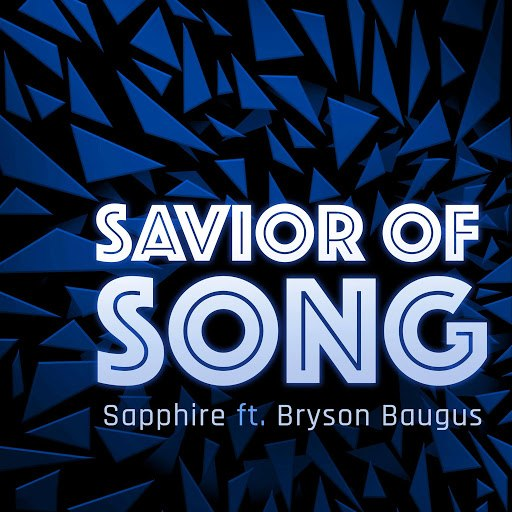How might the color scheme of blues in the 'SAVIOR OF SONG' image affect the viewer's perception of the music? The predominantly blue color scheme in the 'SAVIOR OF SONG' artwork likely evokes feelings of depth and introspection, commonly associated with cooler colors. This could lead listeners to anticipate a song that might explore profound or reflective themes, possibly mixed with a sense of calm or melancholy. The intensity of the darker blues could also suggest underlying energy or richness, aligning with a more dynamic and immersive musical experience. 